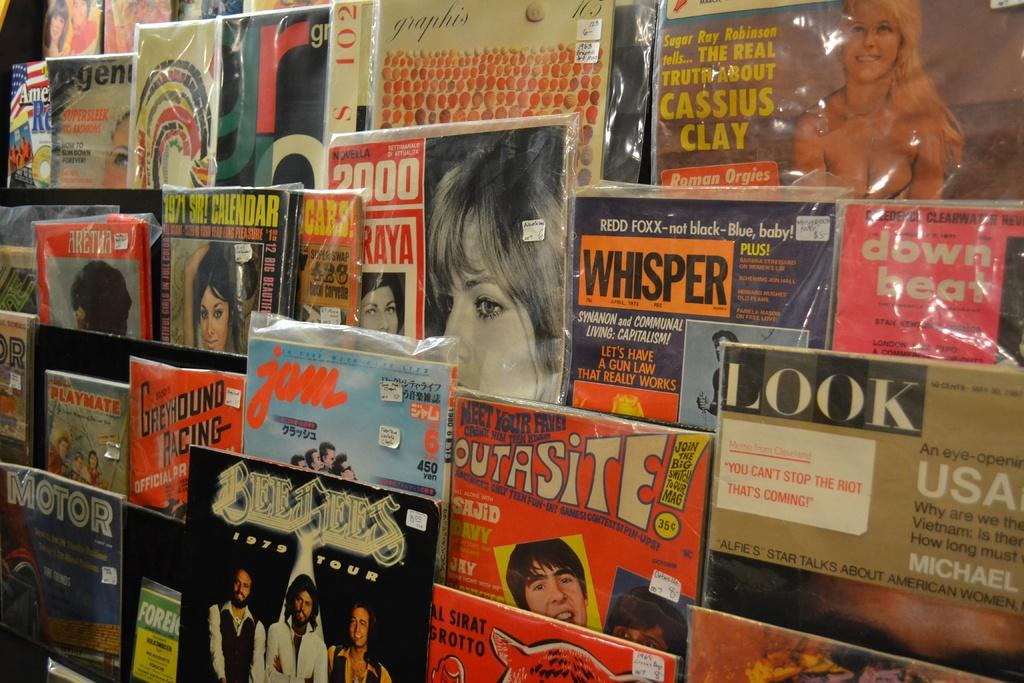<image>
Give a short and clear explanation of the subsequent image. A bunch of magazines on a rack include Jam and Whisper. 